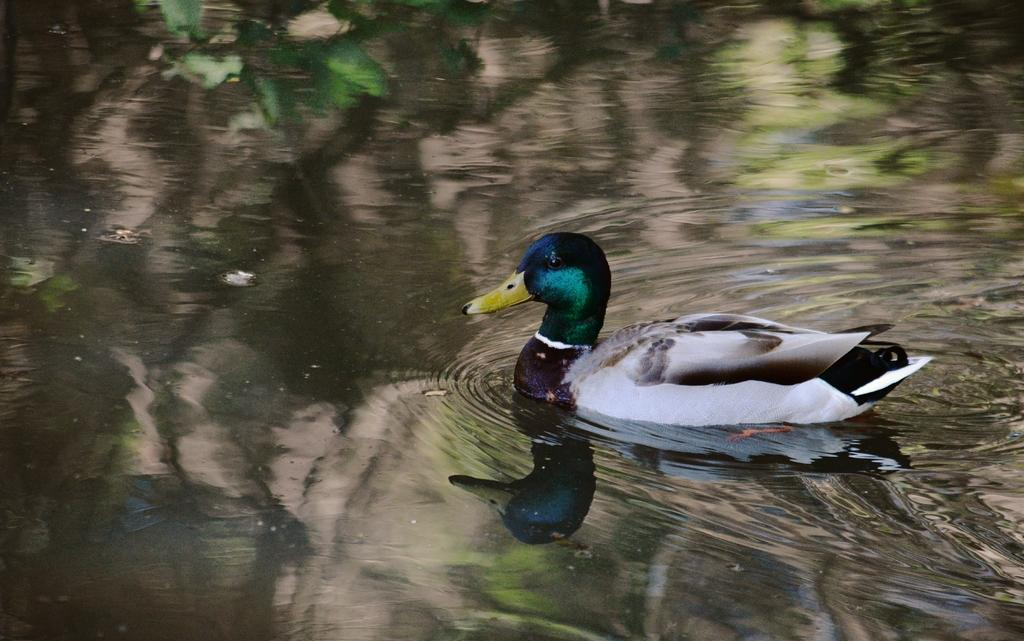What animal can be seen in the image? There is a duck in the image. What is the duck doing in the image? The duck is swimming in the water. What can be seen in the water besides the duck? There is a reflection of trees in the water. What type of honey is being collected by the rat in the image? There is no rat or honey present in the image. The image only features a duck swimming in the water with a reflection of trees. 